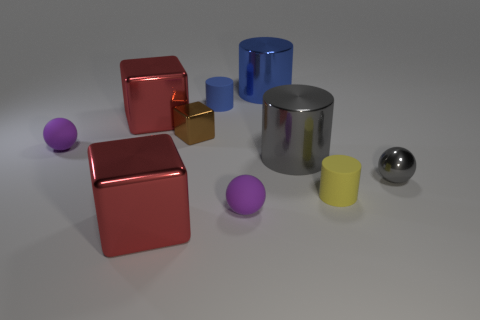Do the small metallic sphere and the metallic cylinder in front of the small block have the same color? While the small metallic sphere and the metallic cylinder might appear to have similar reflective properties, they do not have the same inherent color. The sphere displays distinct reflections of its environment, particularly the purple and yellow blocks, which may influence its perceived color, but the cylinder's surface reflects more of the surrounding grays and blues, indicating its color varies from that of the sphere. 